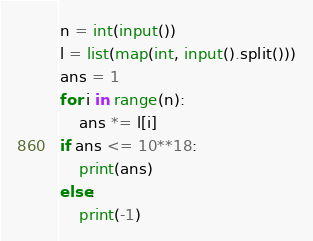Convert code to text. <code><loc_0><loc_0><loc_500><loc_500><_Python_>n = int(input())
l = list(map(int, input().split()))
ans = 1
for i in range(n):
    ans *= l[i]
if ans <= 10**18:
    print(ans)
else:
    print(-1)</code> 